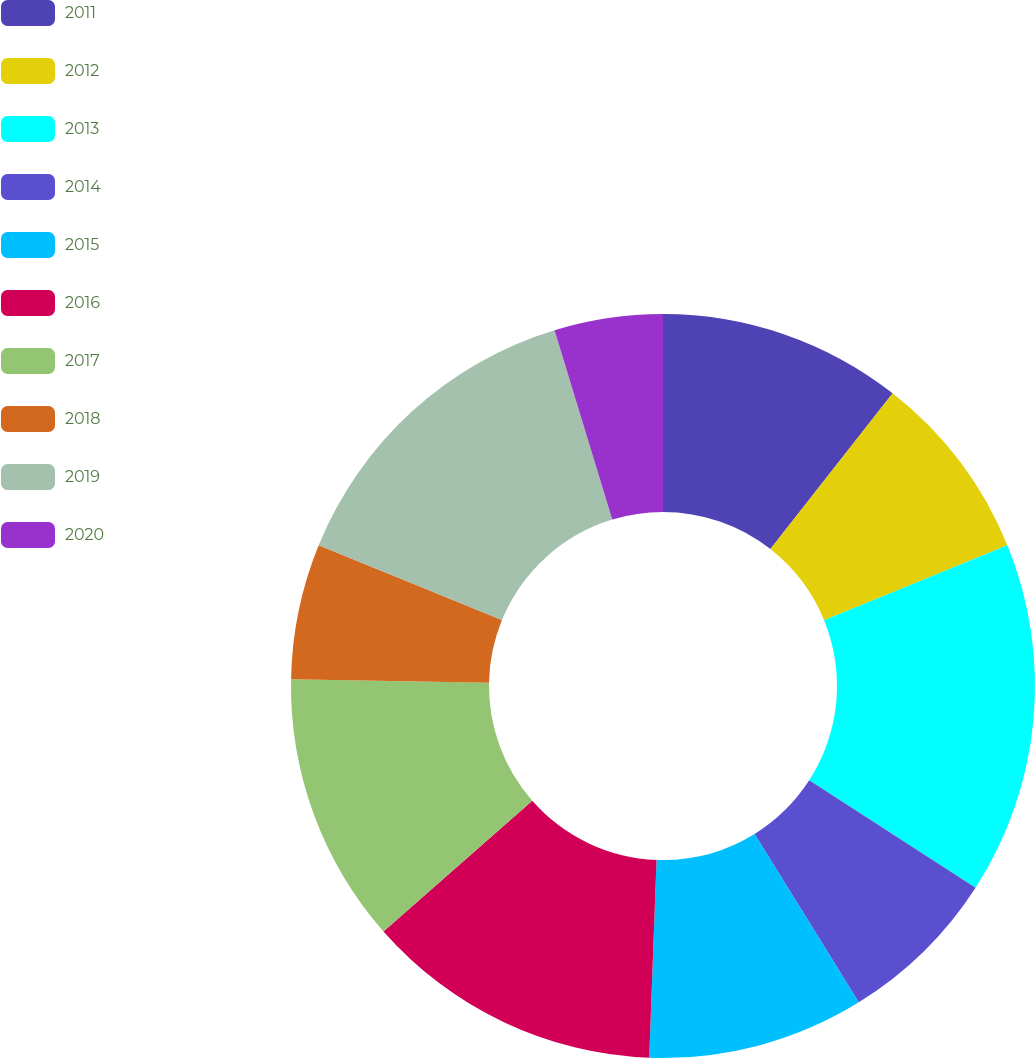<chart> <loc_0><loc_0><loc_500><loc_500><pie_chart><fcel>2011<fcel>2012<fcel>2013<fcel>2014<fcel>2015<fcel>2016<fcel>2017<fcel>2018<fcel>2019<fcel>2020<nl><fcel>10.59%<fcel>8.24%<fcel>15.29%<fcel>7.06%<fcel>9.41%<fcel>12.94%<fcel>11.76%<fcel>5.89%<fcel>14.11%<fcel>4.71%<nl></chart> 